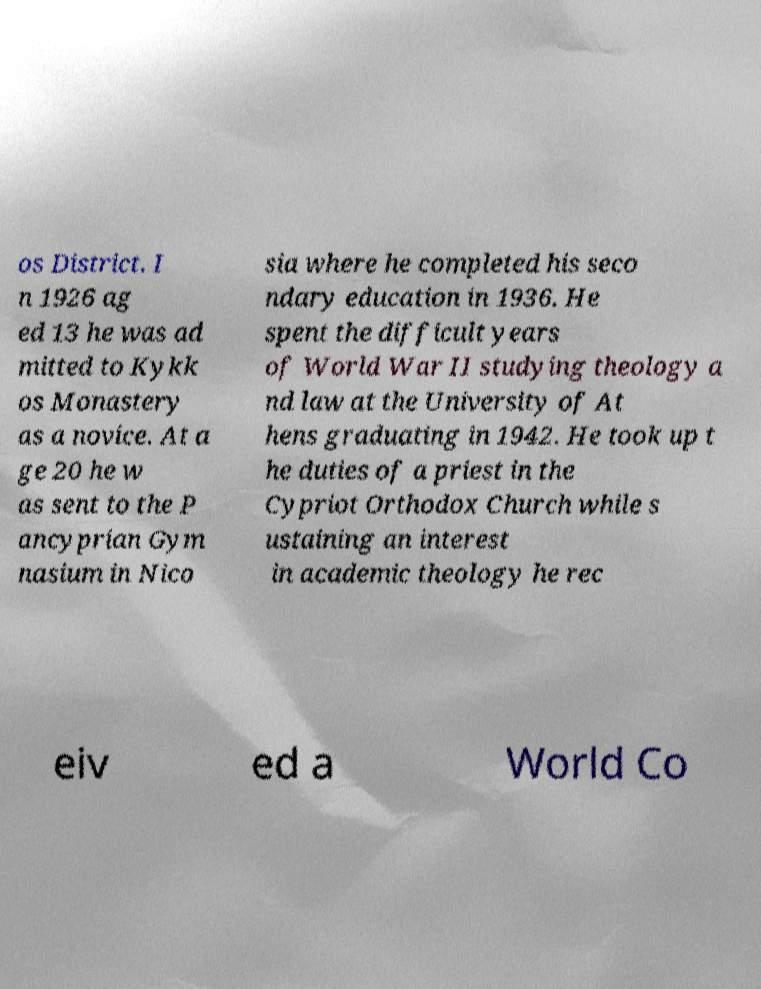I need the written content from this picture converted into text. Can you do that? os District. I n 1926 ag ed 13 he was ad mitted to Kykk os Monastery as a novice. At a ge 20 he w as sent to the P ancyprian Gym nasium in Nico sia where he completed his seco ndary education in 1936. He spent the difficult years of World War II studying theology a nd law at the University of At hens graduating in 1942. He took up t he duties of a priest in the Cypriot Orthodox Church while s ustaining an interest in academic theology he rec eiv ed a World Co 